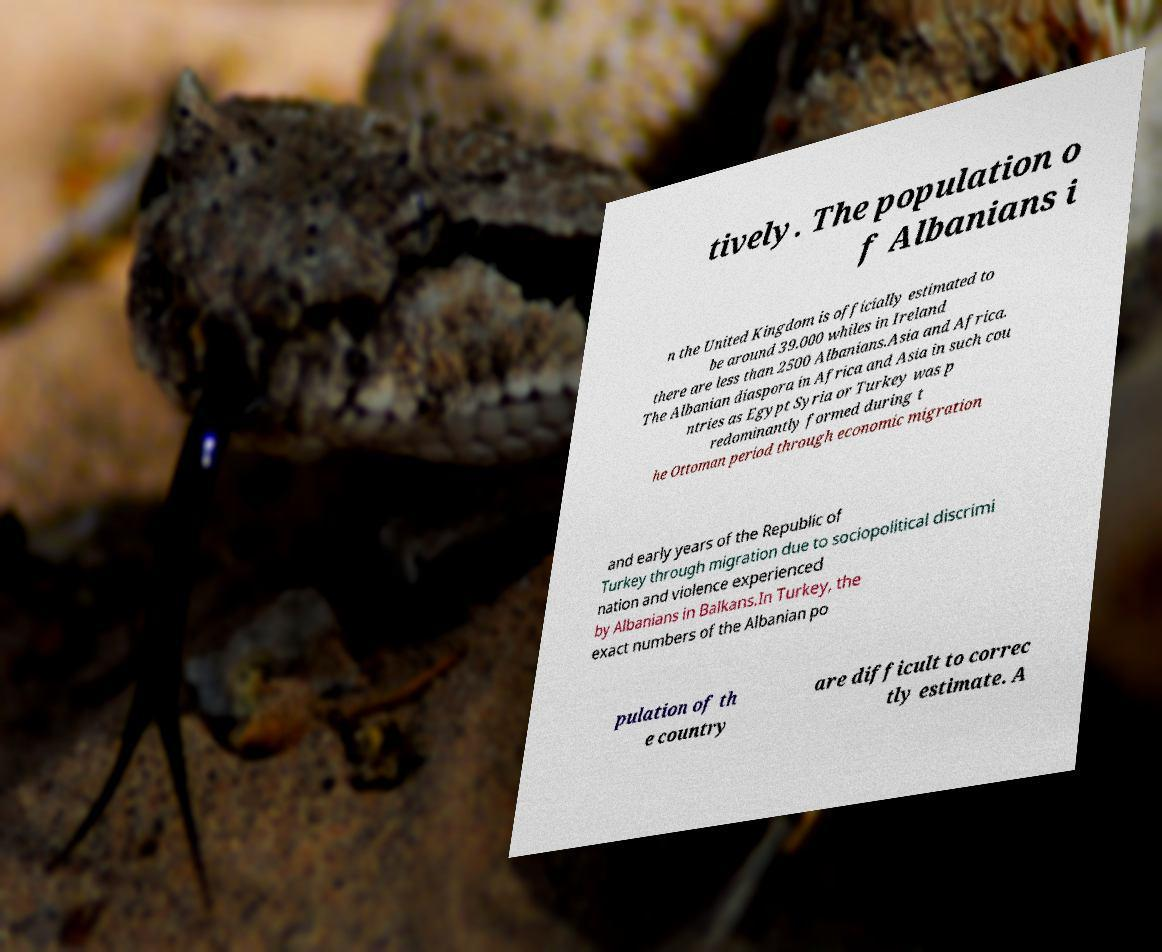Could you extract and type out the text from this image? tively. The population o f Albanians i n the United Kingdom is officially estimated to be around 39.000 whiles in Ireland there are less than 2500 Albanians.Asia and Africa. The Albanian diaspora in Africa and Asia in such cou ntries as Egypt Syria or Turkey was p redominantly formed during t he Ottoman period through economic migration and early years of the Republic of Turkey through migration due to sociopolitical discrimi nation and violence experienced by Albanians in Balkans.In Turkey, the exact numbers of the Albanian po pulation of th e country are difficult to correc tly estimate. A 